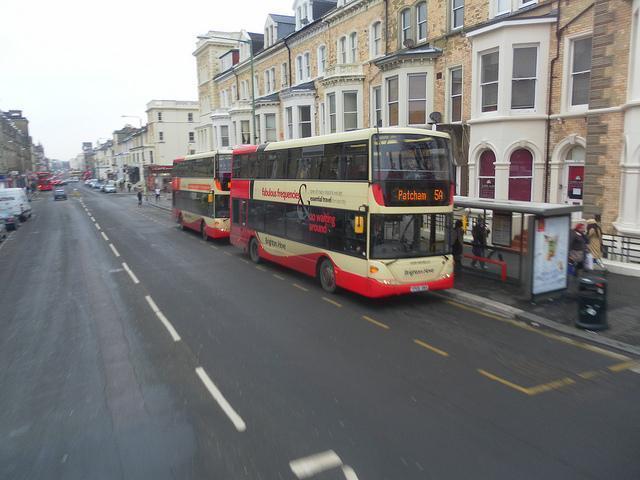When was the double-decker bus invented?
Indicate the correct response by choosing from the four available options to answer the question.
Options: 1910, 1893, 1900, 1906. 1906. 